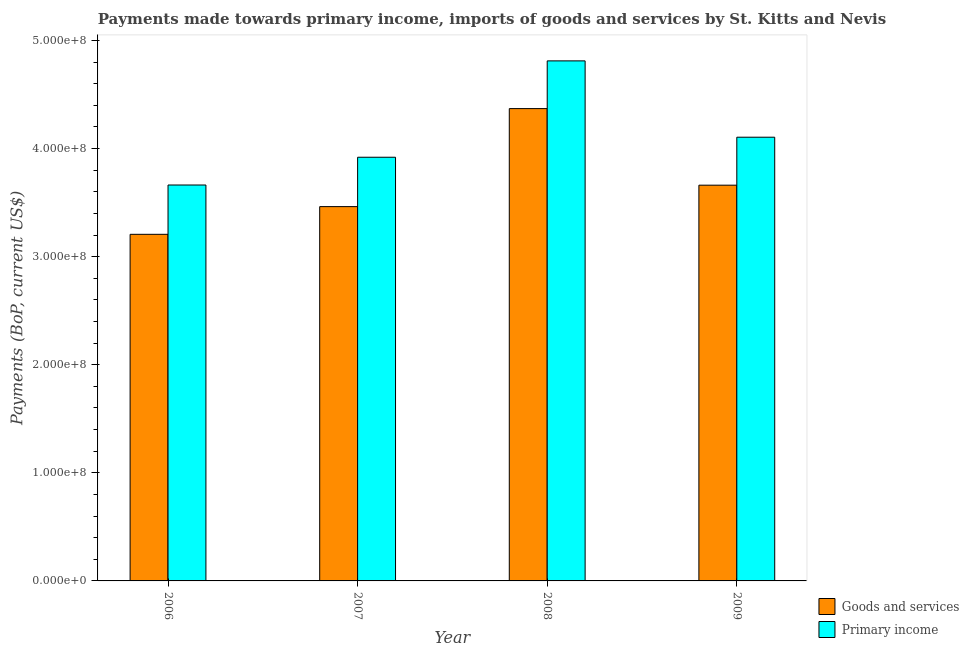Are the number of bars per tick equal to the number of legend labels?
Ensure brevity in your answer.  Yes. How many bars are there on the 4th tick from the right?
Ensure brevity in your answer.  2. What is the payments made towards primary income in 2007?
Your answer should be compact. 3.92e+08. Across all years, what is the maximum payments made towards goods and services?
Give a very brief answer. 4.37e+08. Across all years, what is the minimum payments made towards goods and services?
Your answer should be compact. 3.21e+08. What is the total payments made towards primary income in the graph?
Provide a short and direct response. 1.65e+09. What is the difference between the payments made towards goods and services in 2008 and that in 2009?
Offer a terse response. 7.09e+07. What is the difference between the payments made towards primary income in 2008 and the payments made towards goods and services in 2006?
Keep it short and to the point. 1.15e+08. What is the average payments made towards primary income per year?
Give a very brief answer. 4.13e+08. What is the ratio of the payments made towards primary income in 2006 to that in 2007?
Your answer should be compact. 0.93. Is the payments made towards primary income in 2006 less than that in 2009?
Your answer should be very brief. Yes. Is the difference between the payments made towards primary income in 2006 and 2009 greater than the difference between the payments made towards goods and services in 2006 and 2009?
Your response must be concise. No. What is the difference between the highest and the second highest payments made towards goods and services?
Your response must be concise. 7.09e+07. What is the difference between the highest and the lowest payments made towards primary income?
Make the answer very short. 1.15e+08. In how many years, is the payments made towards goods and services greater than the average payments made towards goods and services taken over all years?
Make the answer very short. 1. Is the sum of the payments made towards primary income in 2006 and 2007 greater than the maximum payments made towards goods and services across all years?
Your answer should be compact. Yes. What does the 1st bar from the left in 2009 represents?
Provide a succinct answer. Goods and services. What does the 2nd bar from the right in 2008 represents?
Provide a succinct answer. Goods and services. Are all the bars in the graph horizontal?
Your answer should be very brief. No. What is the difference between two consecutive major ticks on the Y-axis?
Your answer should be compact. 1.00e+08. Are the values on the major ticks of Y-axis written in scientific E-notation?
Provide a succinct answer. Yes. Does the graph contain grids?
Provide a succinct answer. No. Where does the legend appear in the graph?
Make the answer very short. Bottom right. How many legend labels are there?
Your response must be concise. 2. How are the legend labels stacked?
Provide a short and direct response. Vertical. What is the title of the graph?
Provide a short and direct response. Payments made towards primary income, imports of goods and services by St. Kitts and Nevis. Does "RDB nonconcessional" appear as one of the legend labels in the graph?
Ensure brevity in your answer.  No. What is the label or title of the X-axis?
Keep it short and to the point. Year. What is the label or title of the Y-axis?
Offer a terse response. Payments (BoP, current US$). What is the Payments (BoP, current US$) in Goods and services in 2006?
Your answer should be very brief. 3.21e+08. What is the Payments (BoP, current US$) of Primary income in 2006?
Your answer should be compact. 3.66e+08. What is the Payments (BoP, current US$) of Goods and services in 2007?
Make the answer very short. 3.46e+08. What is the Payments (BoP, current US$) of Primary income in 2007?
Make the answer very short. 3.92e+08. What is the Payments (BoP, current US$) in Goods and services in 2008?
Your answer should be compact. 4.37e+08. What is the Payments (BoP, current US$) of Primary income in 2008?
Your answer should be compact. 4.81e+08. What is the Payments (BoP, current US$) in Goods and services in 2009?
Keep it short and to the point. 3.66e+08. What is the Payments (BoP, current US$) of Primary income in 2009?
Your answer should be very brief. 4.11e+08. Across all years, what is the maximum Payments (BoP, current US$) in Goods and services?
Your answer should be very brief. 4.37e+08. Across all years, what is the maximum Payments (BoP, current US$) of Primary income?
Give a very brief answer. 4.81e+08. Across all years, what is the minimum Payments (BoP, current US$) of Goods and services?
Your answer should be very brief. 3.21e+08. Across all years, what is the minimum Payments (BoP, current US$) in Primary income?
Offer a very short reply. 3.66e+08. What is the total Payments (BoP, current US$) of Goods and services in the graph?
Provide a short and direct response. 1.47e+09. What is the total Payments (BoP, current US$) in Primary income in the graph?
Your answer should be very brief. 1.65e+09. What is the difference between the Payments (BoP, current US$) in Goods and services in 2006 and that in 2007?
Provide a short and direct response. -2.56e+07. What is the difference between the Payments (BoP, current US$) in Primary income in 2006 and that in 2007?
Make the answer very short. -2.57e+07. What is the difference between the Payments (BoP, current US$) of Goods and services in 2006 and that in 2008?
Ensure brevity in your answer.  -1.16e+08. What is the difference between the Payments (BoP, current US$) of Primary income in 2006 and that in 2008?
Make the answer very short. -1.15e+08. What is the difference between the Payments (BoP, current US$) of Goods and services in 2006 and that in 2009?
Provide a succinct answer. -4.55e+07. What is the difference between the Payments (BoP, current US$) in Primary income in 2006 and that in 2009?
Your answer should be very brief. -4.42e+07. What is the difference between the Payments (BoP, current US$) in Goods and services in 2007 and that in 2008?
Keep it short and to the point. -9.07e+07. What is the difference between the Payments (BoP, current US$) in Primary income in 2007 and that in 2008?
Provide a succinct answer. -8.92e+07. What is the difference between the Payments (BoP, current US$) in Goods and services in 2007 and that in 2009?
Make the answer very short. -1.98e+07. What is the difference between the Payments (BoP, current US$) of Primary income in 2007 and that in 2009?
Give a very brief answer. -1.85e+07. What is the difference between the Payments (BoP, current US$) of Goods and services in 2008 and that in 2009?
Make the answer very short. 7.09e+07. What is the difference between the Payments (BoP, current US$) in Primary income in 2008 and that in 2009?
Keep it short and to the point. 7.06e+07. What is the difference between the Payments (BoP, current US$) of Goods and services in 2006 and the Payments (BoP, current US$) of Primary income in 2007?
Make the answer very short. -7.13e+07. What is the difference between the Payments (BoP, current US$) in Goods and services in 2006 and the Payments (BoP, current US$) in Primary income in 2008?
Your answer should be very brief. -1.60e+08. What is the difference between the Payments (BoP, current US$) in Goods and services in 2006 and the Payments (BoP, current US$) in Primary income in 2009?
Your response must be concise. -8.98e+07. What is the difference between the Payments (BoP, current US$) of Goods and services in 2007 and the Payments (BoP, current US$) of Primary income in 2008?
Ensure brevity in your answer.  -1.35e+08. What is the difference between the Payments (BoP, current US$) of Goods and services in 2007 and the Payments (BoP, current US$) of Primary income in 2009?
Provide a short and direct response. -6.42e+07. What is the difference between the Payments (BoP, current US$) of Goods and services in 2008 and the Payments (BoP, current US$) of Primary income in 2009?
Your answer should be compact. 2.65e+07. What is the average Payments (BoP, current US$) of Goods and services per year?
Offer a very short reply. 3.68e+08. What is the average Payments (BoP, current US$) in Primary income per year?
Your answer should be compact. 4.13e+08. In the year 2006, what is the difference between the Payments (BoP, current US$) of Goods and services and Payments (BoP, current US$) of Primary income?
Make the answer very short. -4.56e+07. In the year 2007, what is the difference between the Payments (BoP, current US$) in Goods and services and Payments (BoP, current US$) in Primary income?
Your answer should be very brief. -4.57e+07. In the year 2008, what is the difference between the Payments (BoP, current US$) of Goods and services and Payments (BoP, current US$) of Primary income?
Provide a short and direct response. -4.42e+07. In the year 2009, what is the difference between the Payments (BoP, current US$) in Goods and services and Payments (BoP, current US$) in Primary income?
Make the answer very short. -4.44e+07. What is the ratio of the Payments (BoP, current US$) of Goods and services in 2006 to that in 2007?
Your answer should be compact. 0.93. What is the ratio of the Payments (BoP, current US$) of Primary income in 2006 to that in 2007?
Keep it short and to the point. 0.93. What is the ratio of the Payments (BoP, current US$) of Goods and services in 2006 to that in 2008?
Keep it short and to the point. 0.73. What is the ratio of the Payments (BoP, current US$) in Primary income in 2006 to that in 2008?
Your response must be concise. 0.76. What is the ratio of the Payments (BoP, current US$) of Goods and services in 2006 to that in 2009?
Your answer should be very brief. 0.88. What is the ratio of the Payments (BoP, current US$) in Primary income in 2006 to that in 2009?
Provide a succinct answer. 0.89. What is the ratio of the Payments (BoP, current US$) of Goods and services in 2007 to that in 2008?
Make the answer very short. 0.79. What is the ratio of the Payments (BoP, current US$) in Primary income in 2007 to that in 2008?
Your response must be concise. 0.81. What is the ratio of the Payments (BoP, current US$) in Goods and services in 2007 to that in 2009?
Offer a very short reply. 0.95. What is the ratio of the Payments (BoP, current US$) of Primary income in 2007 to that in 2009?
Ensure brevity in your answer.  0.95. What is the ratio of the Payments (BoP, current US$) of Goods and services in 2008 to that in 2009?
Your response must be concise. 1.19. What is the ratio of the Payments (BoP, current US$) of Primary income in 2008 to that in 2009?
Keep it short and to the point. 1.17. What is the difference between the highest and the second highest Payments (BoP, current US$) of Goods and services?
Provide a short and direct response. 7.09e+07. What is the difference between the highest and the second highest Payments (BoP, current US$) in Primary income?
Your answer should be compact. 7.06e+07. What is the difference between the highest and the lowest Payments (BoP, current US$) in Goods and services?
Provide a short and direct response. 1.16e+08. What is the difference between the highest and the lowest Payments (BoP, current US$) of Primary income?
Provide a succinct answer. 1.15e+08. 